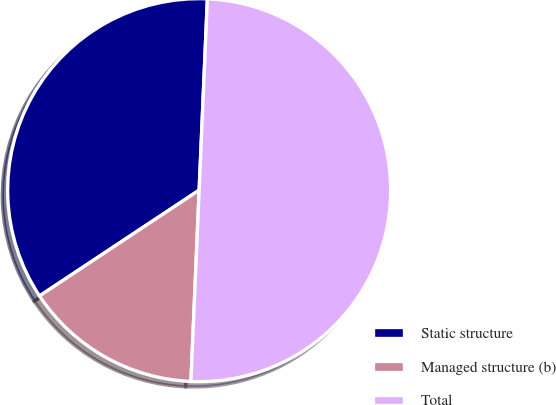<chart> <loc_0><loc_0><loc_500><loc_500><pie_chart><fcel>Static structure<fcel>Managed structure (b)<fcel>Total<nl><fcel>35.0%<fcel>15.0%<fcel>50.0%<nl></chart> 